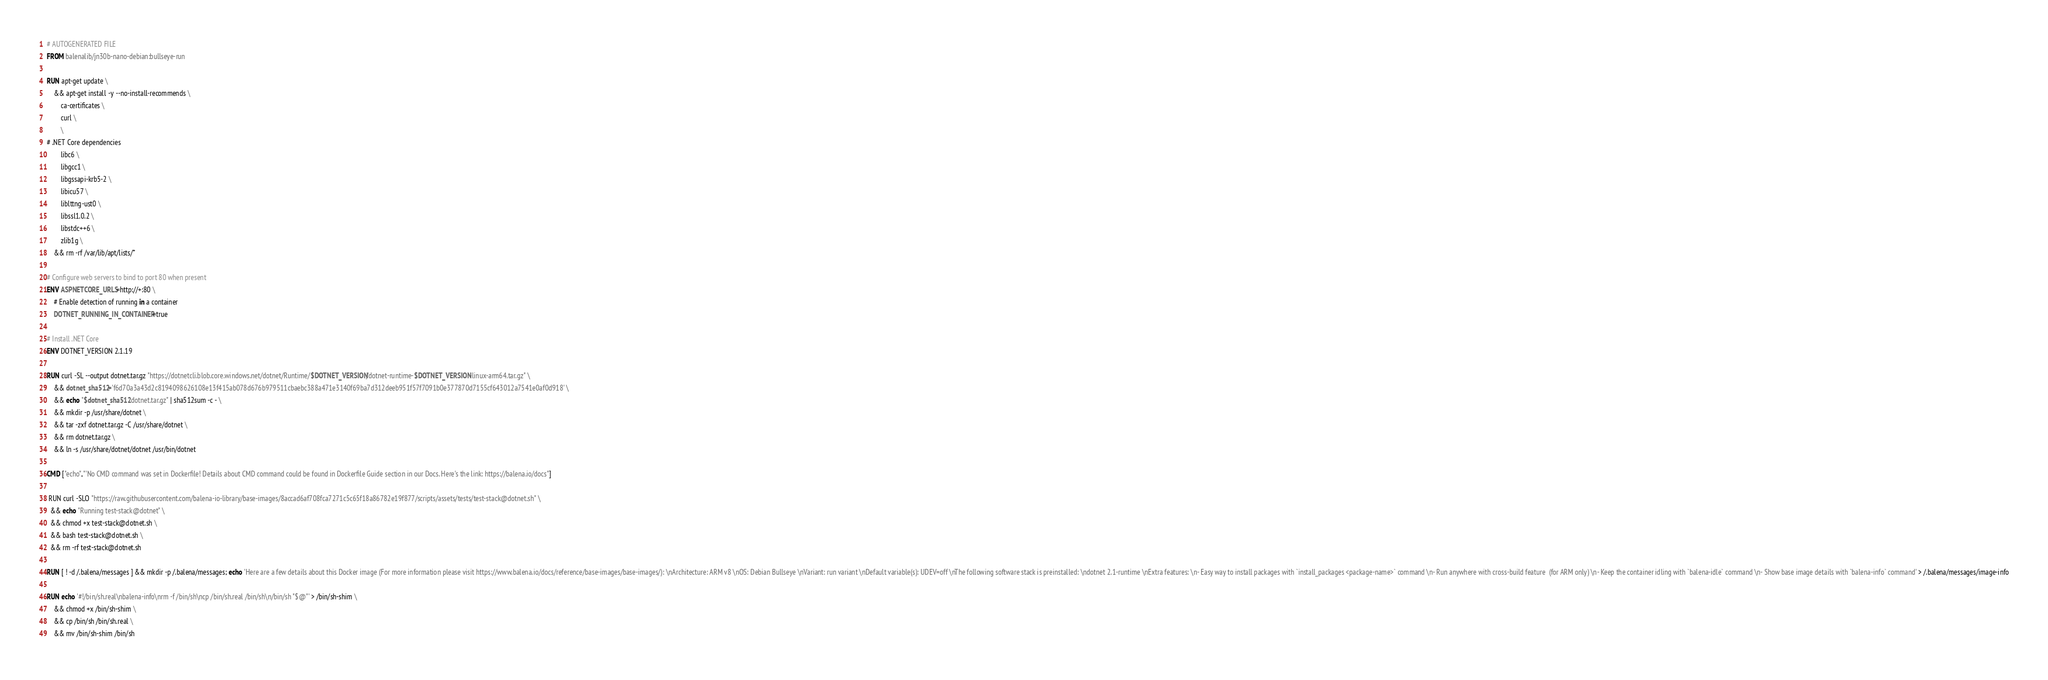<code> <loc_0><loc_0><loc_500><loc_500><_Dockerfile_># AUTOGENERATED FILE
FROM balenalib/jn30b-nano-debian:bullseye-run

RUN apt-get update \
    && apt-get install -y --no-install-recommends \
        ca-certificates \
        curl \
        \
# .NET Core dependencies
        libc6 \
        libgcc1 \
        libgssapi-krb5-2 \
        libicu57 \
        liblttng-ust0 \
        libssl1.0.2 \
        libstdc++6 \
        zlib1g \
    && rm -rf /var/lib/apt/lists/*

# Configure web servers to bind to port 80 when present
ENV ASPNETCORE_URLS=http://+:80 \
    # Enable detection of running in a container
    DOTNET_RUNNING_IN_CONTAINER=true

# Install .NET Core
ENV DOTNET_VERSION 2.1.19

RUN curl -SL --output dotnet.tar.gz "https://dotnetcli.blob.core.windows.net/dotnet/Runtime/$DOTNET_VERSION/dotnet-runtime-$DOTNET_VERSION-linux-arm64.tar.gz" \
    && dotnet_sha512='f6d70a3a43d2c8194098626108e13f415ab078d676b979511cbaebc388a471e3140f69ba7d312deeb951f57f7091b0e377870d7155cf643012a7541e0af0d918' \
    && echo "$dotnet_sha512 dotnet.tar.gz" | sha512sum -c - \
    && mkdir -p /usr/share/dotnet \
    && tar -zxf dotnet.tar.gz -C /usr/share/dotnet \
    && rm dotnet.tar.gz \
    && ln -s /usr/share/dotnet/dotnet /usr/bin/dotnet

CMD ["echo","'No CMD command was set in Dockerfile! Details about CMD command could be found in Dockerfile Guide section in our Docs. Here's the link: https://balena.io/docs"]

 RUN curl -SLO "https://raw.githubusercontent.com/balena-io-library/base-images/8accad6af708fca7271c5c65f18a86782e19f877/scripts/assets/tests/test-stack@dotnet.sh" \
  && echo "Running test-stack@dotnet" \
  && chmod +x test-stack@dotnet.sh \
  && bash test-stack@dotnet.sh \
  && rm -rf test-stack@dotnet.sh 

RUN [ ! -d /.balena/messages ] && mkdir -p /.balena/messages; echo 'Here are a few details about this Docker image (For more information please visit https://www.balena.io/docs/reference/base-images/base-images/): \nArchitecture: ARM v8 \nOS: Debian Bullseye \nVariant: run variant \nDefault variable(s): UDEV=off \nThe following software stack is preinstalled: \ndotnet 2.1-runtime \nExtra features: \n- Easy way to install packages with `install_packages <package-name>` command \n- Run anywhere with cross-build feature  (for ARM only) \n- Keep the container idling with `balena-idle` command \n- Show base image details with `balena-info` command' > /.balena/messages/image-info

RUN echo '#!/bin/sh.real\nbalena-info\nrm -f /bin/sh\ncp /bin/sh.real /bin/sh\n/bin/sh "$@"' > /bin/sh-shim \
	&& chmod +x /bin/sh-shim \
	&& cp /bin/sh /bin/sh.real \
	&& mv /bin/sh-shim /bin/sh</code> 